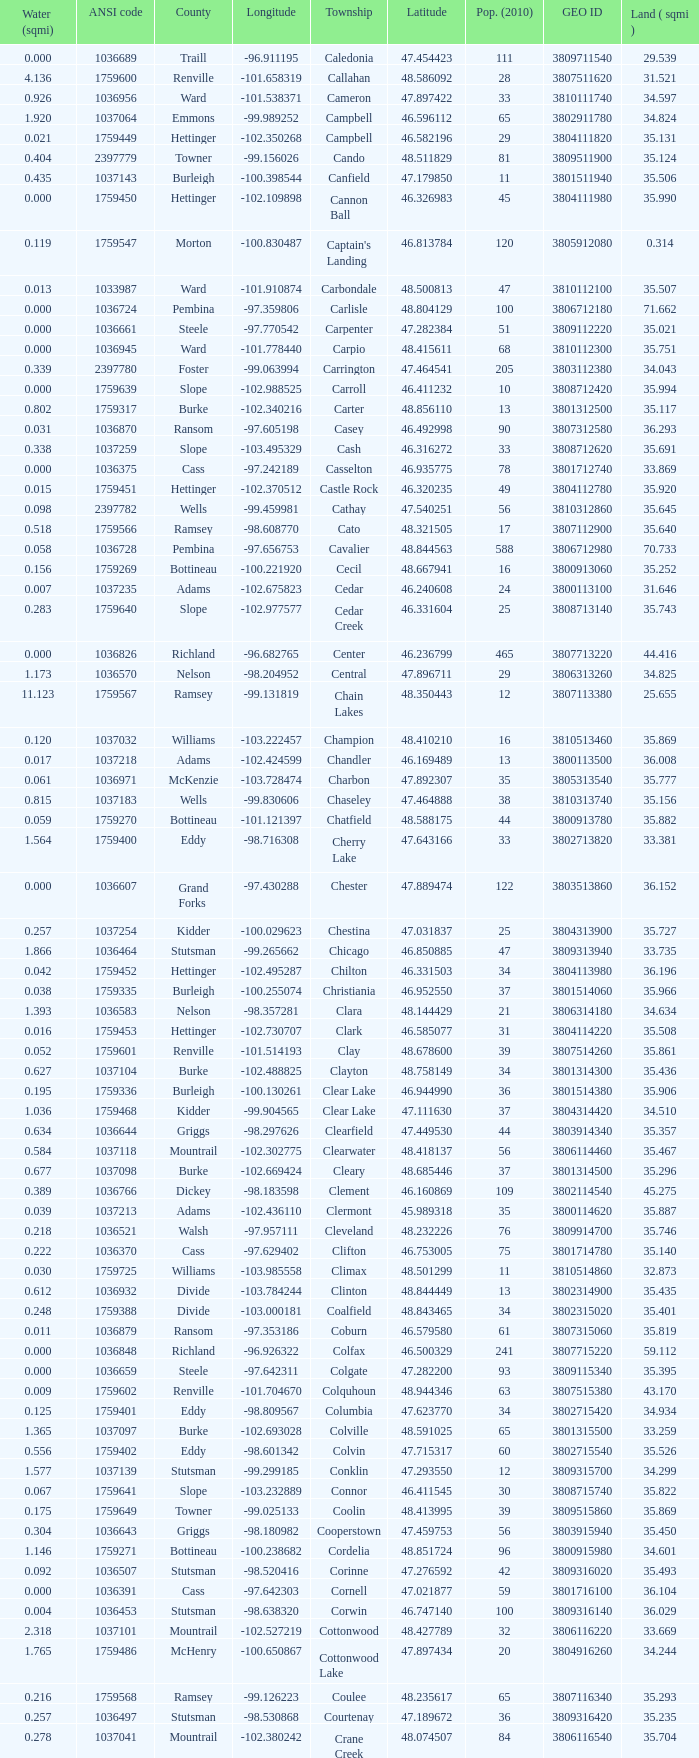What was the county with a longitude of -102.302775? Mountrail. 